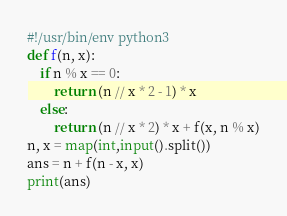<code> <loc_0><loc_0><loc_500><loc_500><_Python_>#!/usr/bin/env python3
def f(n, x):
    if n % x == 0:
        return (n // x * 2 - 1) * x
    else:
        return (n // x * 2) * x + f(x, n % x)
n, x = map(int,input().split())
ans = n + f(n - x, x)
print(ans)</code> 